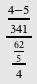<formula> <loc_0><loc_0><loc_500><loc_500>\frac { \frac { 4 - 5 } { 3 4 1 } } { \frac { \frac { 6 2 } { 5 } } { 4 } }</formula> 